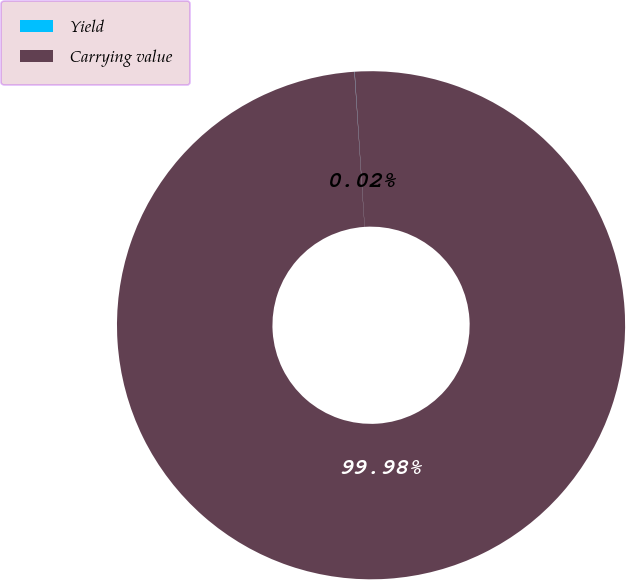<chart> <loc_0><loc_0><loc_500><loc_500><pie_chart><fcel>Yield<fcel>Carrying value<nl><fcel>0.02%<fcel>99.98%<nl></chart> 